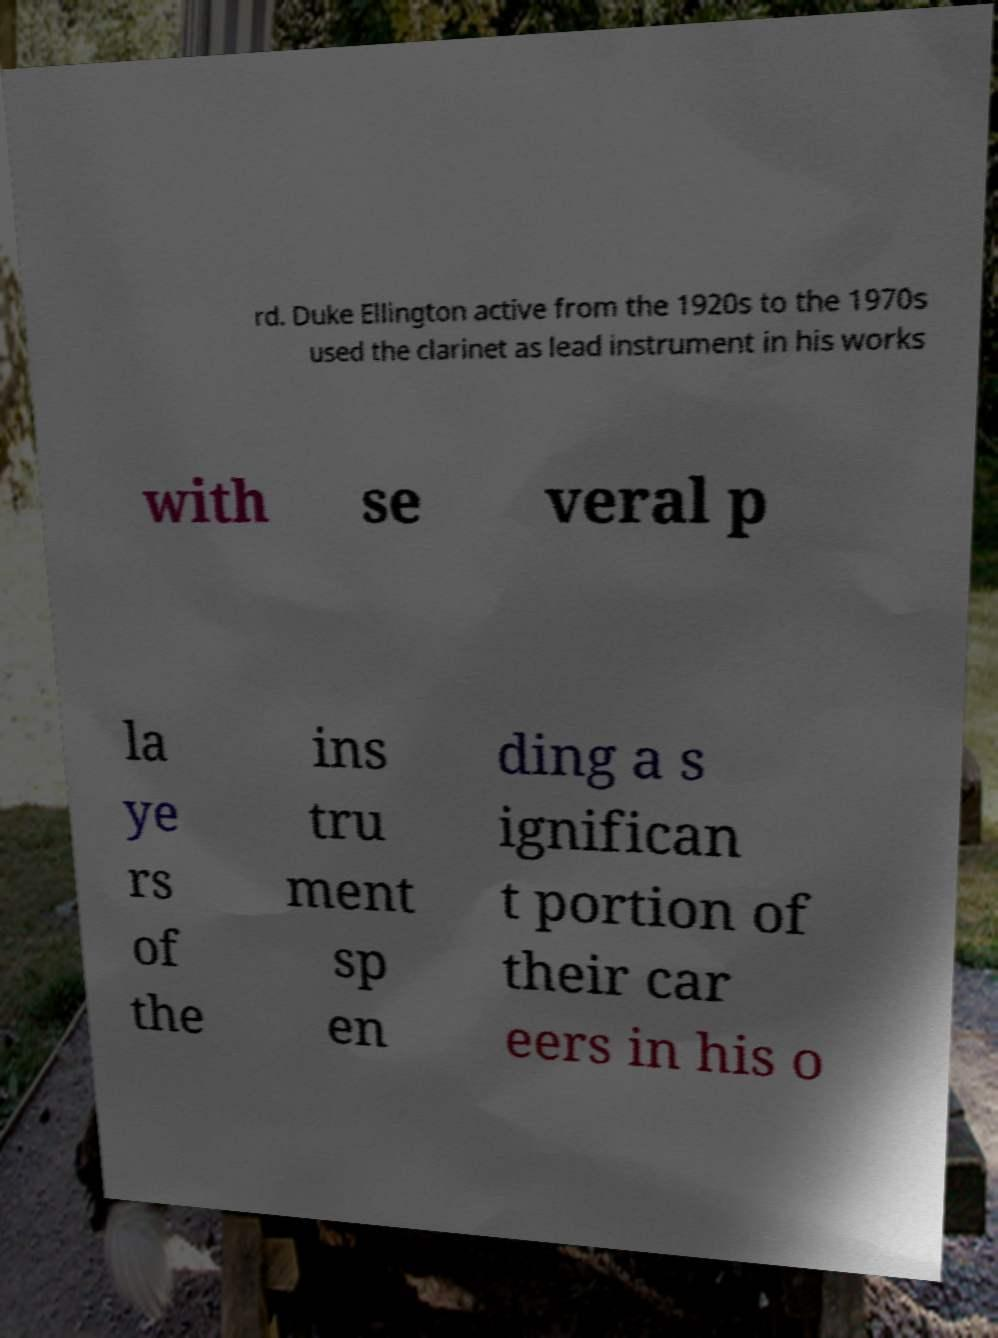Could you assist in decoding the text presented in this image and type it out clearly? rd. Duke Ellington active from the 1920s to the 1970s used the clarinet as lead instrument in his works with se veral p la ye rs of the ins tru ment sp en ding a s ignifican t portion of their car eers in his o 